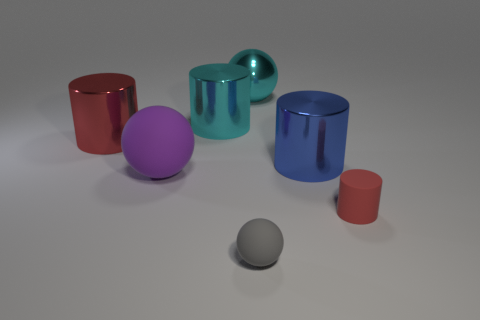Add 2 big green rubber objects. How many objects exist? 9 Subtract all spheres. How many objects are left? 4 Subtract all large blue matte blocks. Subtract all blue cylinders. How many objects are left? 6 Add 6 gray spheres. How many gray spheres are left? 7 Add 6 large blue shiny objects. How many large blue shiny objects exist? 7 Subtract 0 purple blocks. How many objects are left? 7 